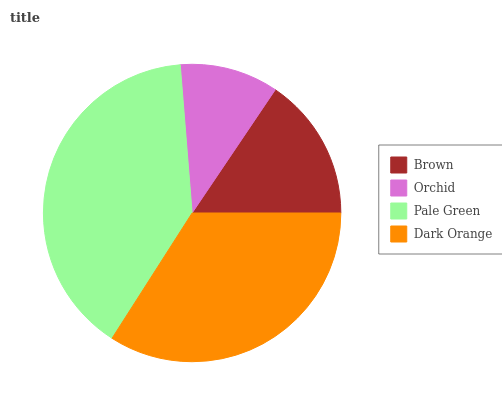Is Orchid the minimum?
Answer yes or no. Yes. Is Pale Green the maximum?
Answer yes or no. Yes. Is Pale Green the minimum?
Answer yes or no. No. Is Orchid the maximum?
Answer yes or no. No. Is Pale Green greater than Orchid?
Answer yes or no. Yes. Is Orchid less than Pale Green?
Answer yes or no. Yes. Is Orchid greater than Pale Green?
Answer yes or no. No. Is Pale Green less than Orchid?
Answer yes or no. No. Is Dark Orange the high median?
Answer yes or no. Yes. Is Brown the low median?
Answer yes or no. Yes. Is Orchid the high median?
Answer yes or no. No. Is Orchid the low median?
Answer yes or no. No. 